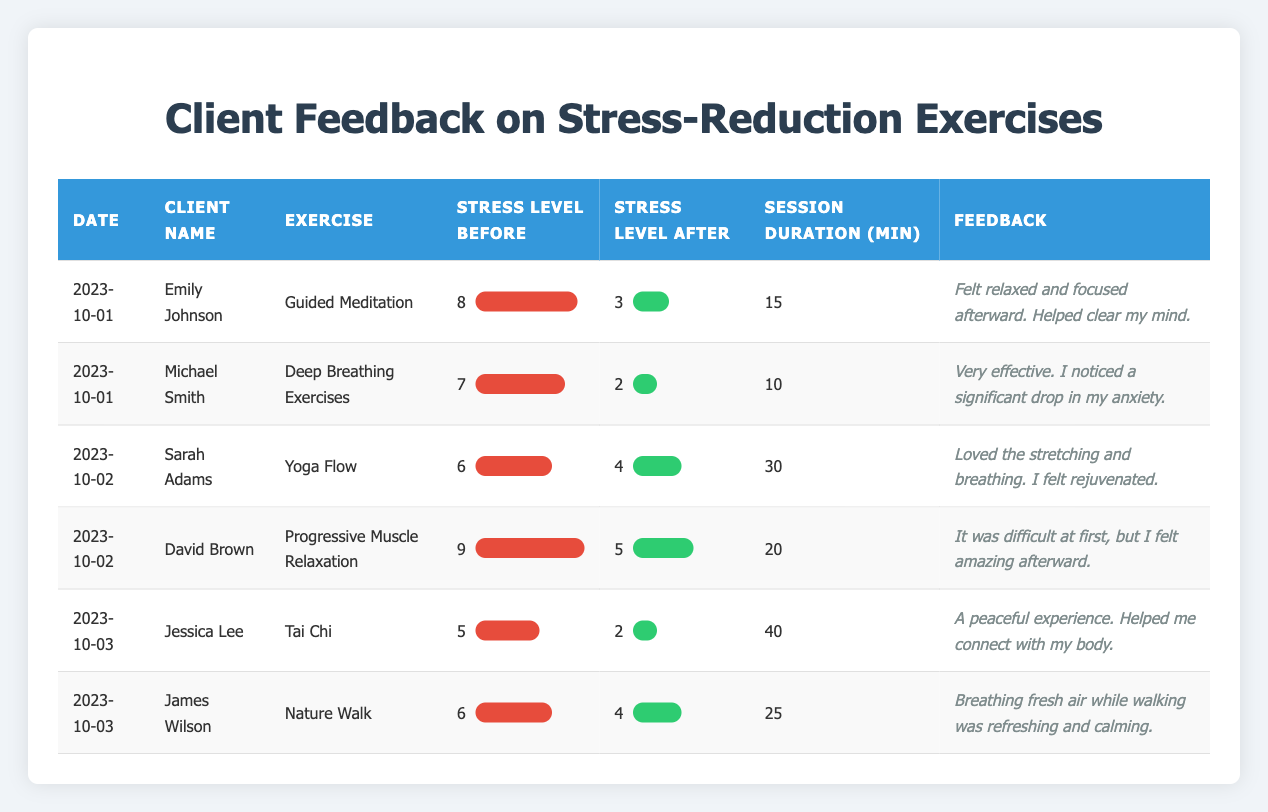What exercise did Emily Johnson participate in on October 1, 2023? The table shows that Emily Johnson participated in "Guided Meditation" on October 1, 2023.
Answer: Guided Meditation What was Michael Smith's stress level before his exercise? The table indicates that Michael Smith had a stress level of 7 before his exercise.
Answer: 7 Did Jessica Lee report a decrease in her stress level after Tai Chi? According to the table, Jessica Lee had a stress level of 5 before Tai Chi and 2 afterward, indicating a decrease in her stress level.
Answer: Yes What was the average session duration for all exercises logged? To find the average session duration, sum up the session durations (15 + 10 + 30 + 20 + 40 + 25 = 140) and divide by the number of entries (6), resulting in an average of 140/6 = 23.33 minutes.
Answer: 23.33 Which exercise had the highest stress level before starting, and what was that level? The table shows that "Progressive Muscle Relaxation" had the highest stress level before starting, which was 9.
Answer: Progressive Muscle Relaxation, 9 How many clients reported their stress level after the exercises? The table lists 6 entries, indicating that all 6 clients reported their stress levels after the exercises.
Answer: 6 What feedback did Sarah Adams give about her experience with Yoga Flow? Sarah Adams stated, "Loved the stretching and breathing. I felt rejuvenated," reflecting her positive experience with Yoga Flow.
Answer: Loved the stretching and breathing. I felt rejuvenated How much did David Brown's stress level decrease after his exercise? David Brown's stress level decreased from 9 to 5, indicating a reduction of 4 points after his exercise.
Answer: 4 What was the combined stress level reduction for all clients? To find the combined stress level reduction, calculate the difference for each entry (e.g., 8-3, 7-2, and so on), which gives us stresses reduced of (5, 5, 2, 4, 3, 2). Summing these reductions (5 + 5 + 2 + 4 + 3 + 2 = 21), the combined reduction is 21.
Answer: 21 